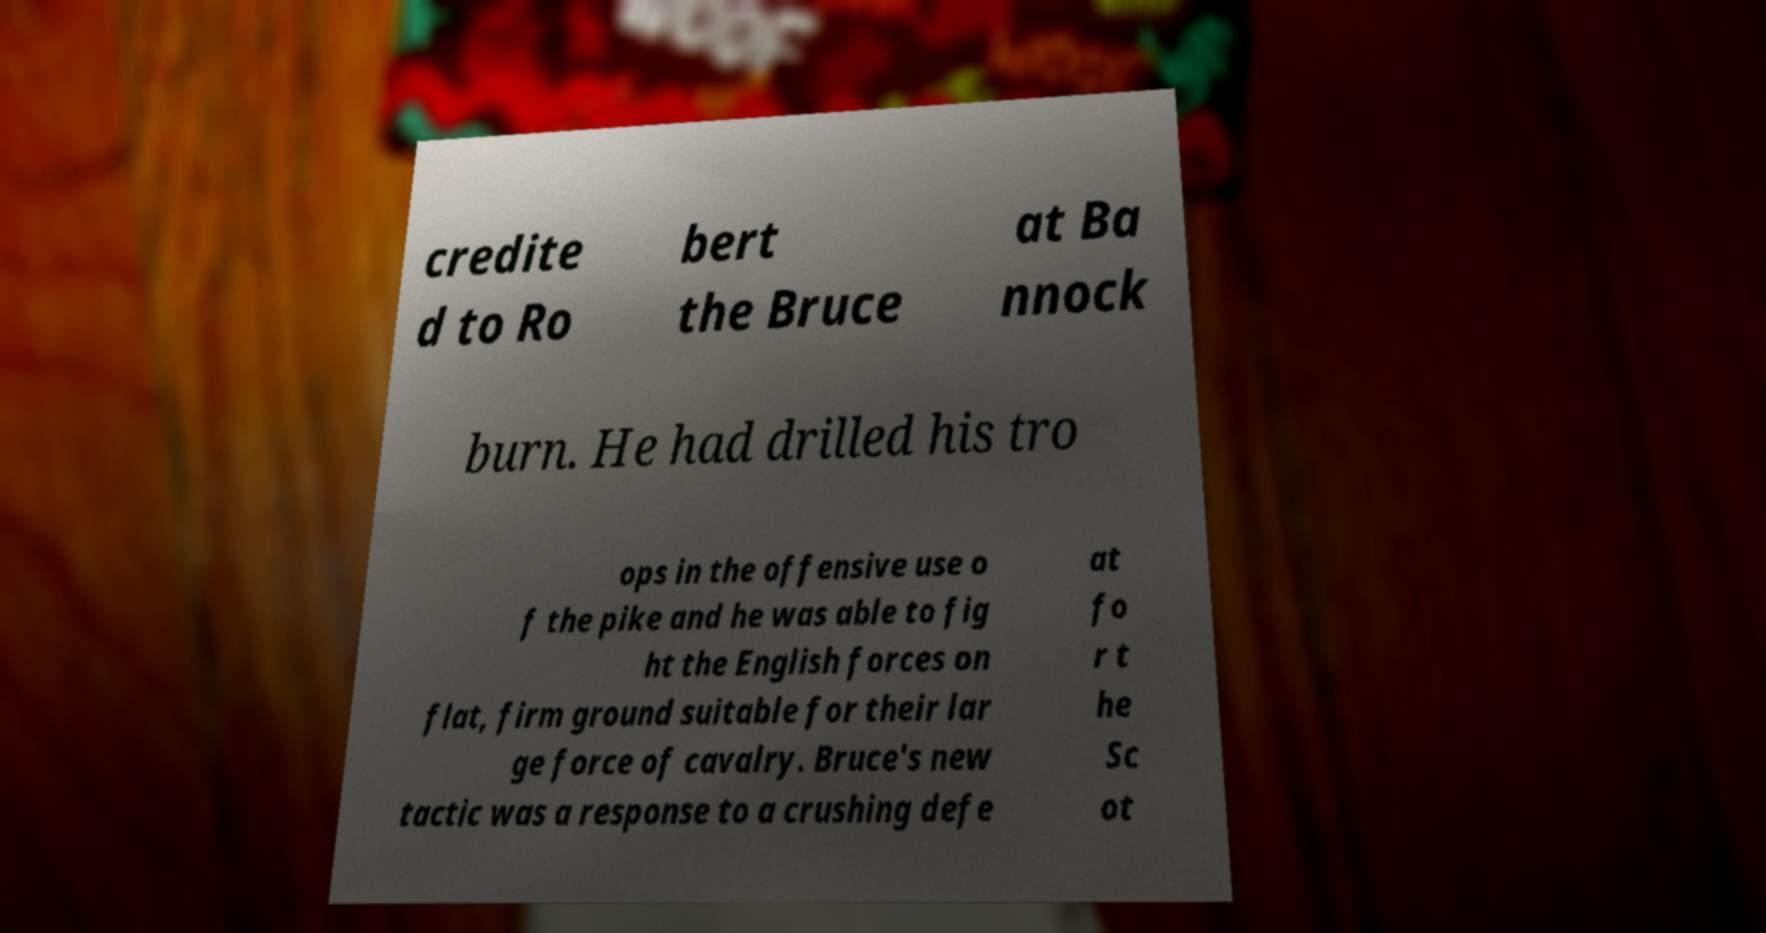Could you assist in decoding the text presented in this image and type it out clearly? credite d to Ro bert the Bruce at Ba nnock burn. He had drilled his tro ops in the offensive use o f the pike and he was able to fig ht the English forces on flat, firm ground suitable for their lar ge force of cavalry. Bruce's new tactic was a response to a crushing defe at fo r t he Sc ot 